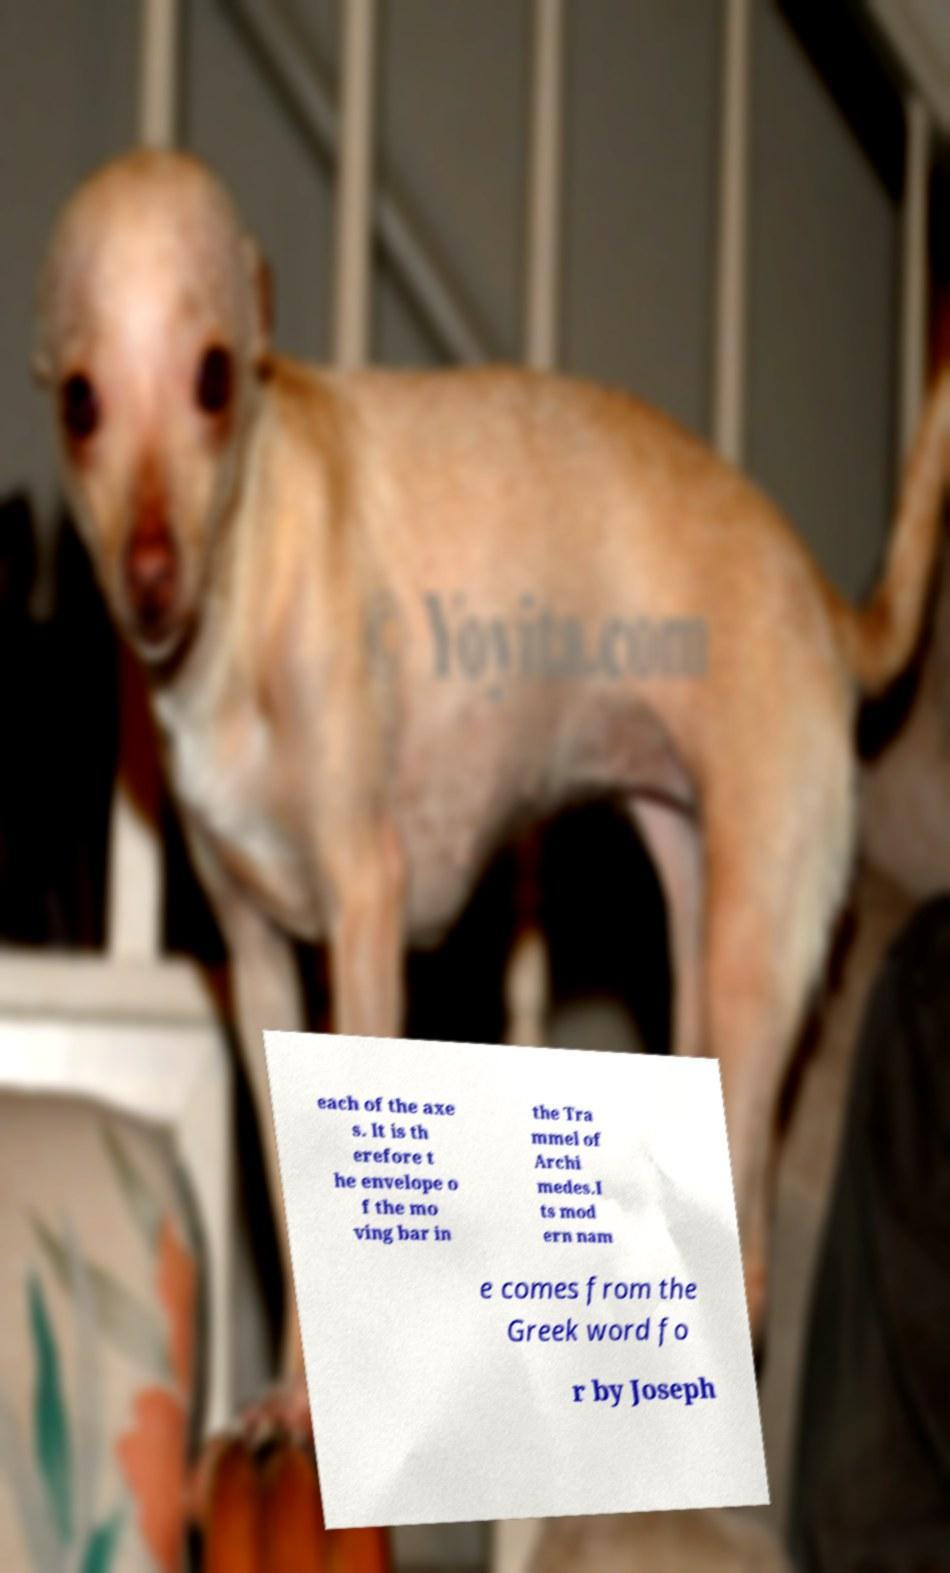Please identify and transcribe the text found in this image. each of the axe s. It is th erefore t he envelope o f the mo ving bar in the Tra mmel of Archi medes.I ts mod ern nam e comes from the Greek word fo r by Joseph 